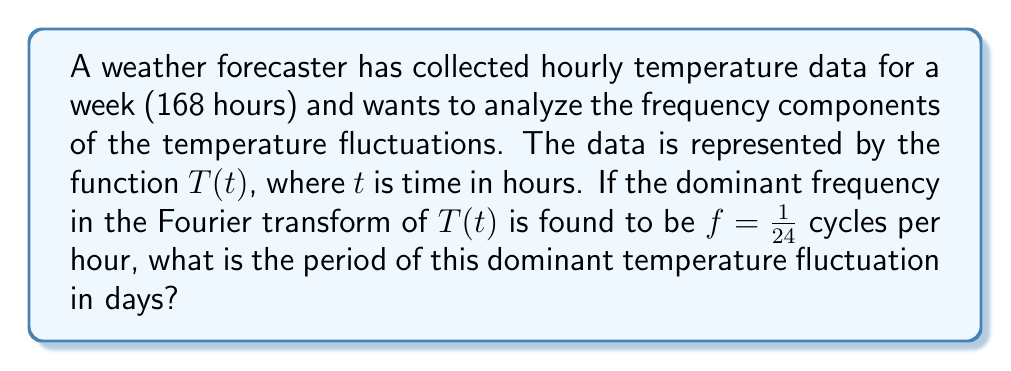Can you answer this question? To solve this problem, we'll follow these steps:

1) The frequency $f$ is given in cycles per hour:

   $f = \frac{1}{24}$ cycles/hour

2) The period $P$ is the inverse of the frequency:

   $P = \frac{1}{f} = \frac{1}{\frac{1}{24}} = 24$ hours

3) We need to convert this to days. There are 24 hours in a day, so:

   $P = \frac{24 \text{ hours}}{24 \text{ hours/day}} = 1$ day

This result makes sense in the context of weather forecasting, as it indicates a daily cycle in temperature fluctuations, likely corresponding to the day-night cycle.
Answer: 1 day 